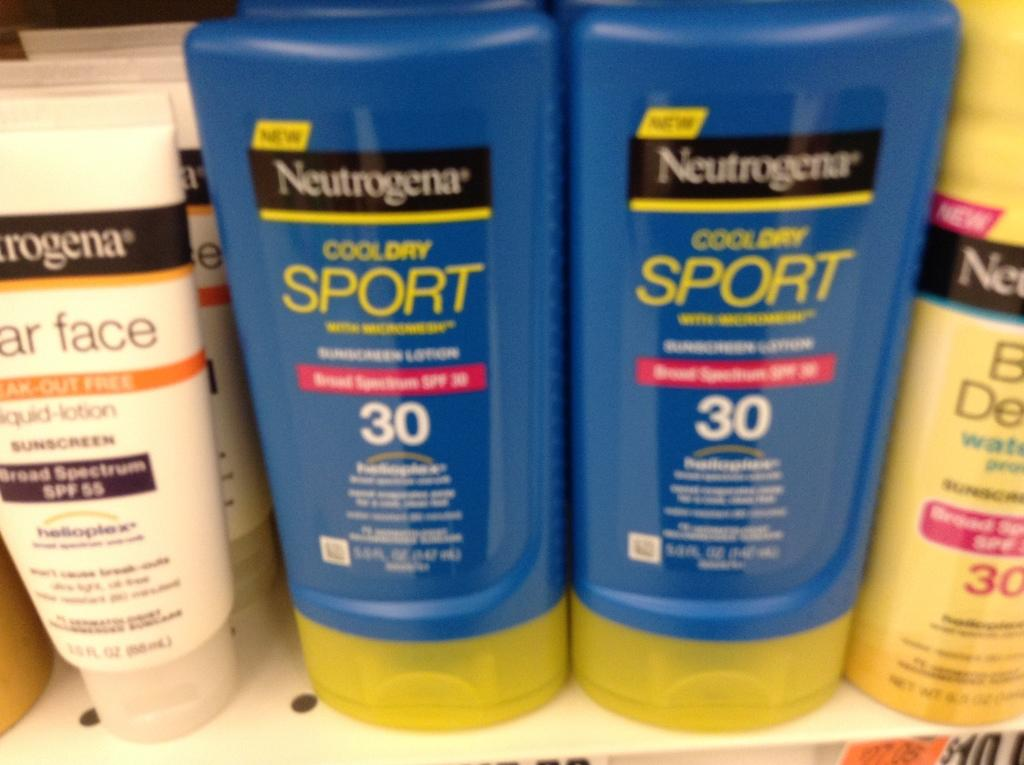<image>
Give a short and clear explanation of the subsequent image. Bottles of Neutrogena  in between some other bottles at a store. 